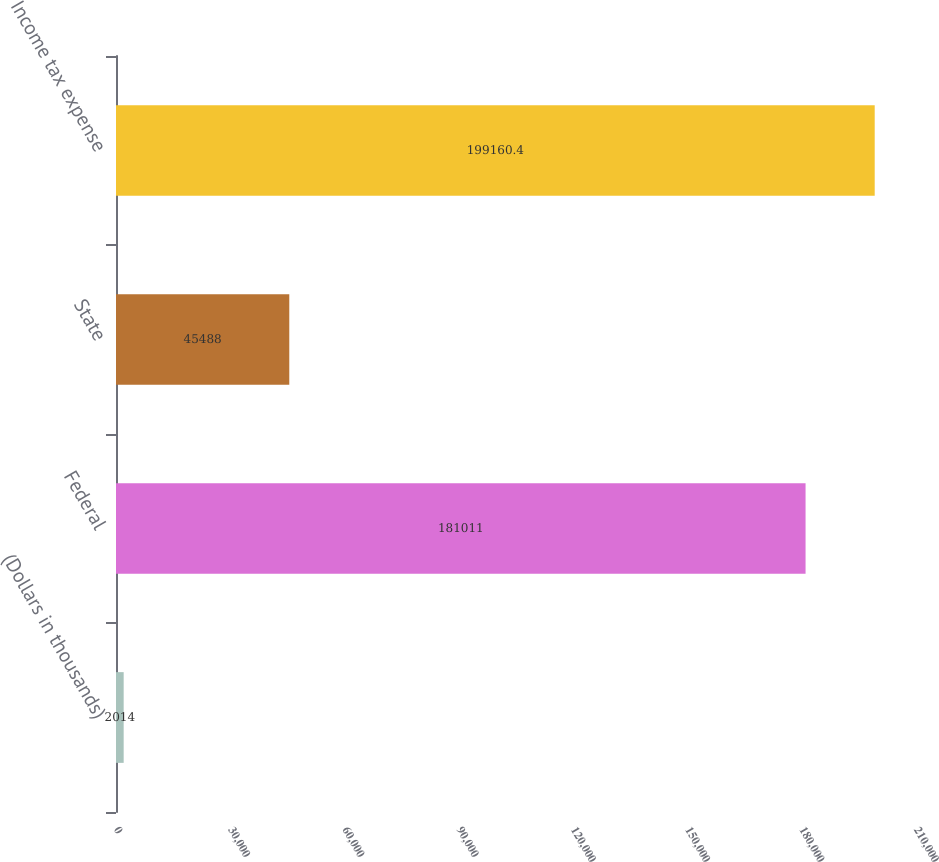Convert chart. <chart><loc_0><loc_0><loc_500><loc_500><bar_chart><fcel>(Dollars in thousands)<fcel>Federal<fcel>State<fcel>Income tax expense<nl><fcel>2014<fcel>181011<fcel>45488<fcel>199160<nl></chart> 